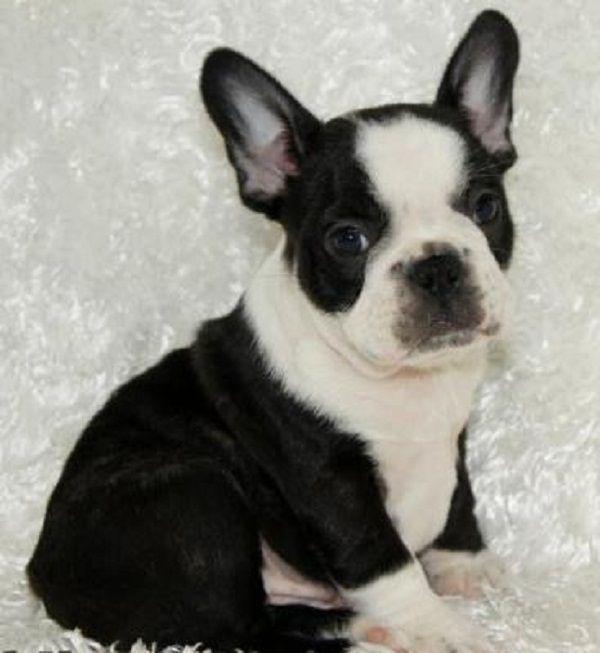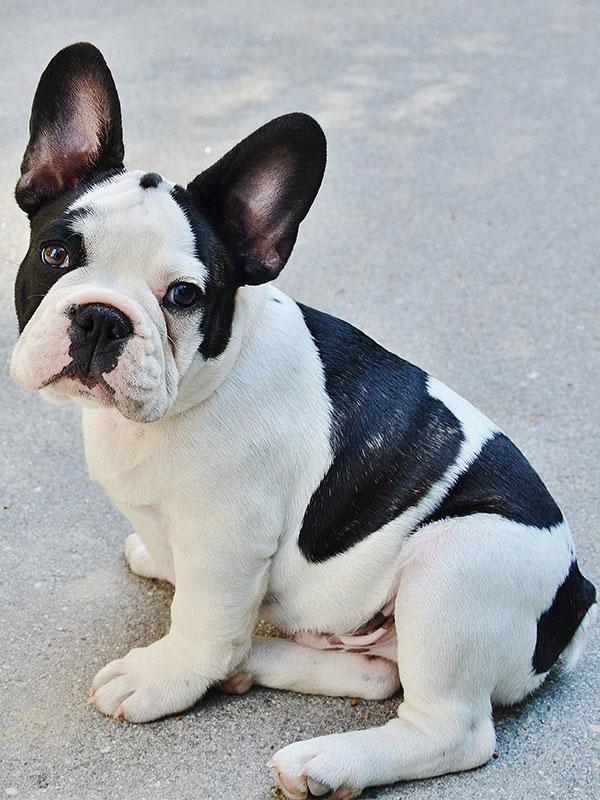The first image is the image on the left, the second image is the image on the right. Evaluate the accuracy of this statement regarding the images: "There is more than one dog in the right image.". Is it true? Answer yes or no. No. The first image is the image on the left, the second image is the image on the right. Examine the images to the left and right. Is the description "Each image contains exactly one dog, and each has black and white markings." accurate? Answer yes or no. Yes. 